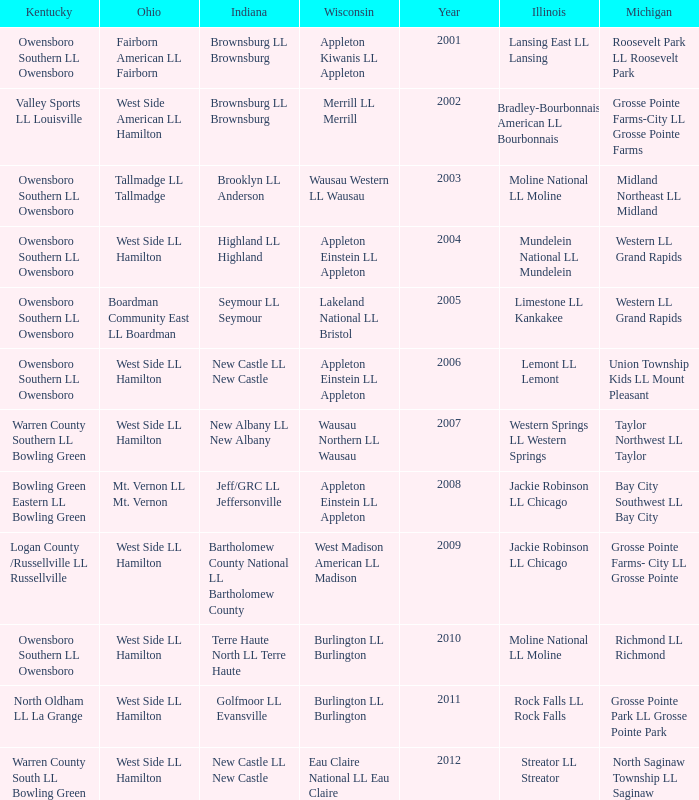What was the little league team from Kentucky when the little league team from Illinois was Rock Falls LL Rock Falls? North Oldham LL La Grange. 